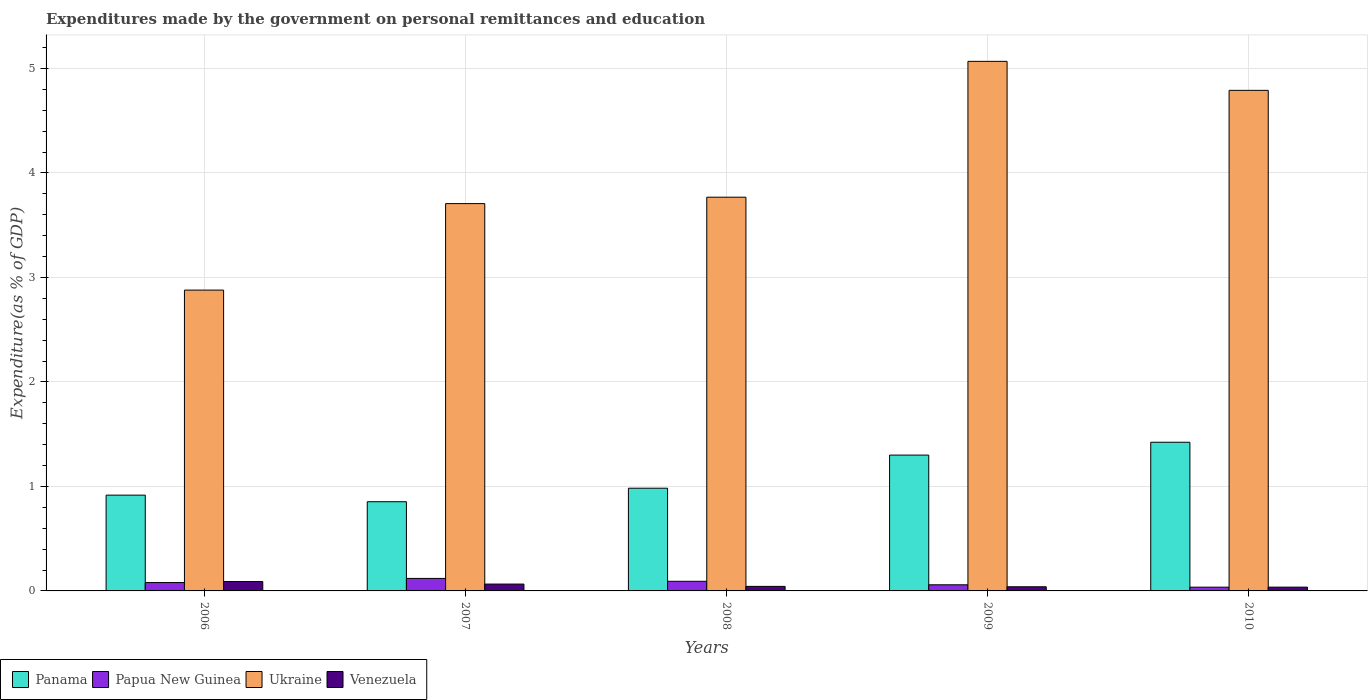Are the number of bars per tick equal to the number of legend labels?
Provide a short and direct response. Yes. Are the number of bars on each tick of the X-axis equal?
Provide a succinct answer. Yes. How many bars are there on the 1st tick from the left?
Your answer should be very brief. 4. How many bars are there on the 4th tick from the right?
Keep it short and to the point. 4. What is the label of the 2nd group of bars from the left?
Your response must be concise. 2007. What is the expenditures made by the government on personal remittances and education in Papua New Guinea in 2008?
Provide a short and direct response. 0.09. Across all years, what is the maximum expenditures made by the government on personal remittances and education in Ukraine?
Your answer should be compact. 5.07. Across all years, what is the minimum expenditures made by the government on personal remittances and education in Panama?
Give a very brief answer. 0.85. What is the total expenditures made by the government on personal remittances and education in Ukraine in the graph?
Give a very brief answer. 20.21. What is the difference between the expenditures made by the government on personal remittances and education in Venezuela in 2006 and that in 2007?
Your response must be concise. 0.02. What is the difference between the expenditures made by the government on personal remittances and education in Panama in 2010 and the expenditures made by the government on personal remittances and education in Venezuela in 2009?
Your response must be concise. 1.38. What is the average expenditures made by the government on personal remittances and education in Panama per year?
Your response must be concise. 1.1. In the year 2007, what is the difference between the expenditures made by the government on personal remittances and education in Papua New Guinea and expenditures made by the government on personal remittances and education in Ukraine?
Your answer should be very brief. -3.59. In how many years, is the expenditures made by the government on personal remittances and education in Ukraine greater than 2.4 %?
Keep it short and to the point. 5. What is the ratio of the expenditures made by the government on personal remittances and education in Venezuela in 2008 to that in 2009?
Ensure brevity in your answer.  1.09. What is the difference between the highest and the second highest expenditures made by the government on personal remittances and education in Panama?
Your response must be concise. 0.12. What is the difference between the highest and the lowest expenditures made by the government on personal remittances and education in Ukraine?
Your response must be concise. 2.19. What does the 2nd bar from the left in 2009 represents?
Offer a terse response. Papua New Guinea. What does the 3rd bar from the right in 2009 represents?
Keep it short and to the point. Papua New Guinea. How many bars are there?
Keep it short and to the point. 20. How many years are there in the graph?
Your answer should be compact. 5. Are the values on the major ticks of Y-axis written in scientific E-notation?
Keep it short and to the point. No. Does the graph contain any zero values?
Provide a succinct answer. No. Does the graph contain grids?
Keep it short and to the point. Yes. How are the legend labels stacked?
Your answer should be very brief. Horizontal. What is the title of the graph?
Provide a short and direct response. Expenditures made by the government on personal remittances and education. What is the label or title of the X-axis?
Offer a very short reply. Years. What is the label or title of the Y-axis?
Make the answer very short. Expenditure(as % of GDP). What is the Expenditure(as % of GDP) in Panama in 2006?
Offer a terse response. 0.92. What is the Expenditure(as % of GDP) of Papua New Guinea in 2006?
Give a very brief answer. 0.08. What is the Expenditure(as % of GDP) of Ukraine in 2006?
Offer a very short reply. 2.88. What is the Expenditure(as % of GDP) in Venezuela in 2006?
Offer a terse response. 0.09. What is the Expenditure(as % of GDP) of Panama in 2007?
Your answer should be compact. 0.85. What is the Expenditure(as % of GDP) in Papua New Guinea in 2007?
Make the answer very short. 0.12. What is the Expenditure(as % of GDP) of Ukraine in 2007?
Provide a short and direct response. 3.71. What is the Expenditure(as % of GDP) of Venezuela in 2007?
Provide a succinct answer. 0.07. What is the Expenditure(as % of GDP) of Panama in 2008?
Provide a short and direct response. 0.98. What is the Expenditure(as % of GDP) in Papua New Guinea in 2008?
Make the answer very short. 0.09. What is the Expenditure(as % of GDP) in Ukraine in 2008?
Provide a succinct answer. 3.77. What is the Expenditure(as % of GDP) of Venezuela in 2008?
Offer a very short reply. 0.04. What is the Expenditure(as % of GDP) in Panama in 2009?
Offer a terse response. 1.3. What is the Expenditure(as % of GDP) of Papua New Guinea in 2009?
Offer a terse response. 0.06. What is the Expenditure(as % of GDP) of Ukraine in 2009?
Make the answer very short. 5.07. What is the Expenditure(as % of GDP) in Venezuela in 2009?
Provide a succinct answer. 0.04. What is the Expenditure(as % of GDP) in Panama in 2010?
Provide a short and direct response. 1.42. What is the Expenditure(as % of GDP) of Papua New Guinea in 2010?
Your response must be concise. 0.04. What is the Expenditure(as % of GDP) of Ukraine in 2010?
Your answer should be very brief. 4.79. What is the Expenditure(as % of GDP) in Venezuela in 2010?
Provide a succinct answer. 0.04. Across all years, what is the maximum Expenditure(as % of GDP) of Panama?
Ensure brevity in your answer.  1.42. Across all years, what is the maximum Expenditure(as % of GDP) of Papua New Guinea?
Provide a succinct answer. 0.12. Across all years, what is the maximum Expenditure(as % of GDP) of Ukraine?
Offer a very short reply. 5.07. Across all years, what is the maximum Expenditure(as % of GDP) in Venezuela?
Offer a terse response. 0.09. Across all years, what is the minimum Expenditure(as % of GDP) in Panama?
Provide a succinct answer. 0.85. Across all years, what is the minimum Expenditure(as % of GDP) in Papua New Guinea?
Give a very brief answer. 0.04. Across all years, what is the minimum Expenditure(as % of GDP) in Ukraine?
Make the answer very short. 2.88. Across all years, what is the minimum Expenditure(as % of GDP) in Venezuela?
Ensure brevity in your answer.  0.04. What is the total Expenditure(as % of GDP) of Panama in the graph?
Offer a very short reply. 5.48. What is the total Expenditure(as % of GDP) in Papua New Guinea in the graph?
Your answer should be compact. 0.39. What is the total Expenditure(as % of GDP) in Ukraine in the graph?
Provide a short and direct response. 20.21. What is the total Expenditure(as % of GDP) of Venezuela in the graph?
Keep it short and to the point. 0.28. What is the difference between the Expenditure(as % of GDP) in Panama in 2006 and that in 2007?
Your answer should be very brief. 0.06. What is the difference between the Expenditure(as % of GDP) of Papua New Guinea in 2006 and that in 2007?
Your response must be concise. -0.04. What is the difference between the Expenditure(as % of GDP) in Ukraine in 2006 and that in 2007?
Provide a succinct answer. -0.83. What is the difference between the Expenditure(as % of GDP) in Venezuela in 2006 and that in 2007?
Offer a terse response. 0.02. What is the difference between the Expenditure(as % of GDP) in Panama in 2006 and that in 2008?
Your answer should be very brief. -0.07. What is the difference between the Expenditure(as % of GDP) in Papua New Guinea in 2006 and that in 2008?
Make the answer very short. -0.01. What is the difference between the Expenditure(as % of GDP) in Ukraine in 2006 and that in 2008?
Offer a terse response. -0.89. What is the difference between the Expenditure(as % of GDP) of Venezuela in 2006 and that in 2008?
Make the answer very short. 0.05. What is the difference between the Expenditure(as % of GDP) of Panama in 2006 and that in 2009?
Keep it short and to the point. -0.38. What is the difference between the Expenditure(as % of GDP) in Papua New Guinea in 2006 and that in 2009?
Keep it short and to the point. 0.02. What is the difference between the Expenditure(as % of GDP) in Ukraine in 2006 and that in 2009?
Give a very brief answer. -2.19. What is the difference between the Expenditure(as % of GDP) in Venezuela in 2006 and that in 2009?
Make the answer very short. 0.05. What is the difference between the Expenditure(as % of GDP) in Panama in 2006 and that in 2010?
Your response must be concise. -0.51. What is the difference between the Expenditure(as % of GDP) of Papua New Guinea in 2006 and that in 2010?
Give a very brief answer. 0.04. What is the difference between the Expenditure(as % of GDP) in Ukraine in 2006 and that in 2010?
Provide a succinct answer. -1.91. What is the difference between the Expenditure(as % of GDP) of Venezuela in 2006 and that in 2010?
Offer a very short reply. 0.05. What is the difference between the Expenditure(as % of GDP) of Panama in 2007 and that in 2008?
Your answer should be very brief. -0.13. What is the difference between the Expenditure(as % of GDP) in Papua New Guinea in 2007 and that in 2008?
Your response must be concise. 0.03. What is the difference between the Expenditure(as % of GDP) of Ukraine in 2007 and that in 2008?
Ensure brevity in your answer.  -0.06. What is the difference between the Expenditure(as % of GDP) in Venezuela in 2007 and that in 2008?
Ensure brevity in your answer.  0.02. What is the difference between the Expenditure(as % of GDP) in Panama in 2007 and that in 2009?
Keep it short and to the point. -0.45. What is the difference between the Expenditure(as % of GDP) of Papua New Guinea in 2007 and that in 2009?
Keep it short and to the point. 0.06. What is the difference between the Expenditure(as % of GDP) of Ukraine in 2007 and that in 2009?
Your answer should be very brief. -1.36. What is the difference between the Expenditure(as % of GDP) of Venezuela in 2007 and that in 2009?
Give a very brief answer. 0.03. What is the difference between the Expenditure(as % of GDP) in Panama in 2007 and that in 2010?
Your answer should be compact. -0.57. What is the difference between the Expenditure(as % of GDP) in Papua New Guinea in 2007 and that in 2010?
Make the answer very short. 0.08. What is the difference between the Expenditure(as % of GDP) in Ukraine in 2007 and that in 2010?
Provide a succinct answer. -1.08. What is the difference between the Expenditure(as % of GDP) in Venezuela in 2007 and that in 2010?
Keep it short and to the point. 0.03. What is the difference between the Expenditure(as % of GDP) of Panama in 2008 and that in 2009?
Make the answer very short. -0.32. What is the difference between the Expenditure(as % of GDP) of Papua New Guinea in 2008 and that in 2009?
Your response must be concise. 0.03. What is the difference between the Expenditure(as % of GDP) of Venezuela in 2008 and that in 2009?
Your response must be concise. 0. What is the difference between the Expenditure(as % of GDP) in Panama in 2008 and that in 2010?
Offer a very short reply. -0.44. What is the difference between the Expenditure(as % of GDP) in Papua New Guinea in 2008 and that in 2010?
Make the answer very short. 0.06. What is the difference between the Expenditure(as % of GDP) in Ukraine in 2008 and that in 2010?
Your answer should be very brief. -1.02. What is the difference between the Expenditure(as % of GDP) in Venezuela in 2008 and that in 2010?
Give a very brief answer. 0.01. What is the difference between the Expenditure(as % of GDP) in Panama in 2009 and that in 2010?
Your response must be concise. -0.12. What is the difference between the Expenditure(as % of GDP) of Papua New Guinea in 2009 and that in 2010?
Your response must be concise. 0.02. What is the difference between the Expenditure(as % of GDP) of Ukraine in 2009 and that in 2010?
Give a very brief answer. 0.28. What is the difference between the Expenditure(as % of GDP) of Venezuela in 2009 and that in 2010?
Ensure brevity in your answer.  0. What is the difference between the Expenditure(as % of GDP) of Panama in 2006 and the Expenditure(as % of GDP) of Papua New Guinea in 2007?
Provide a short and direct response. 0.8. What is the difference between the Expenditure(as % of GDP) of Panama in 2006 and the Expenditure(as % of GDP) of Ukraine in 2007?
Provide a short and direct response. -2.79. What is the difference between the Expenditure(as % of GDP) of Panama in 2006 and the Expenditure(as % of GDP) of Venezuela in 2007?
Your answer should be very brief. 0.85. What is the difference between the Expenditure(as % of GDP) in Papua New Guinea in 2006 and the Expenditure(as % of GDP) in Ukraine in 2007?
Your answer should be very brief. -3.63. What is the difference between the Expenditure(as % of GDP) in Papua New Guinea in 2006 and the Expenditure(as % of GDP) in Venezuela in 2007?
Keep it short and to the point. 0.01. What is the difference between the Expenditure(as % of GDP) of Ukraine in 2006 and the Expenditure(as % of GDP) of Venezuela in 2007?
Your answer should be very brief. 2.81. What is the difference between the Expenditure(as % of GDP) in Panama in 2006 and the Expenditure(as % of GDP) in Papua New Guinea in 2008?
Provide a short and direct response. 0.82. What is the difference between the Expenditure(as % of GDP) of Panama in 2006 and the Expenditure(as % of GDP) of Ukraine in 2008?
Offer a very short reply. -2.85. What is the difference between the Expenditure(as % of GDP) in Panama in 2006 and the Expenditure(as % of GDP) in Venezuela in 2008?
Provide a short and direct response. 0.87. What is the difference between the Expenditure(as % of GDP) in Papua New Guinea in 2006 and the Expenditure(as % of GDP) in Ukraine in 2008?
Provide a succinct answer. -3.69. What is the difference between the Expenditure(as % of GDP) of Papua New Guinea in 2006 and the Expenditure(as % of GDP) of Venezuela in 2008?
Your response must be concise. 0.04. What is the difference between the Expenditure(as % of GDP) of Ukraine in 2006 and the Expenditure(as % of GDP) of Venezuela in 2008?
Give a very brief answer. 2.84. What is the difference between the Expenditure(as % of GDP) in Panama in 2006 and the Expenditure(as % of GDP) in Papua New Guinea in 2009?
Offer a very short reply. 0.86. What is the difference between the Expenditure(as % of GDP) in Panama in 2006 and the Expenditure(as % of GDP) in Ukraine in 2009?
Offer a very short reply. -4.15. What is the difference between the Expenditure(as % of GDP) of Panama in 2006 and the Expenditure(as % of GDP) of Venezuela in 2009?
Your response must be concise. 0.88. What is the difference between the Expenditure(as % of GDP) in Papua New Guinea in 2006 and the Expenditure(as % of GDP) in Ukraine in 2009?
Your answer should be very brief. -4.99. What is the difference between the Expenditure(as % of GDP) of Papua New Guinea in 2006 and the Expenditure(as % of GDP) of Venezuela in 2009?
Your answer should be very brief. 0.04. What is the difference between the Expenditure(as % of GDP) in Ukraine in 2006 and the Expenditure(as % of GDP) in Venezuela in 2009?
Your answer should be compact. 2.84. What is the difference between the Expenditure(as % of GDP) of Panama in 2006 and the Expenditure(as % of GDP) of Papua New Guinea in 2010?
Your answer should be very brief. 0.88. What is the difference between the Expenditure(as % of GDP) in Panama in 2006 and the Expenditure(as % of GDP) in Ukraine in 2010?
Give a very brief answer. -3.87. What is the difference between the Expenditure(as % of GDP) of Panama in 2006 and the Expenditure(as % of GDP) of Venezuela in 2010?
Offer a terse response. 0.88. What is the difference between the Expenditure(as % of GDP) of Papua New Guinea in 2006 and the Expenditure(as % of GDP) of Ukraine in 2010?
Offer a very short reply. -4.71. What is the difference between the Expenditure(as % of GDP) in Papua New Guinea in 2006 and the Expenditure(as % of GDP) in Venezuela in 2010?
Offer a terse response. 0.04. What is the difference between the Expenditure(as % of GDP) of Ukraine in 2006 and the Expenditure(as % of GDP) of Venezuela in 2010?
Ensure brevity in your answer.  2.84. What is the difference between the Expenditure(as % of GDP) in Panama in 2007 and the Expenditure(as % of GDP) in Papua New Guinea in 2008?
Your answer should be very brief. 0.76. What is the difference between the Expenditure(as % of GDP) of Panama in 2007 and the Expenditure(as % of GDP) of Ukraine in 2008?
Your answer should be very brief. -2.91. What is the difference between the Expenditure(as % of GDP) of Panama in 2007 and the Expenditure(as % of GDP) of Venezuela in 2008?
Your answer should be compact. 0.81. What is the difference between the Expenditure(as % of GDP) in Papua New Guinea in 2007 and the Expenditure(as % of GDP) in Ukraine in 2008?
Your answer should be compact. -3.65. What is the difference between the Expenditure(as % of GDP) in Papua New Guinea in 2007 and the Expenditure(as % of GDP) in Venezuela in 2008?
Give a very brief answer. 0.08. What is the difference between the Expenditure(as % of GDP) in Ukraine in 2007 and the Expenditure(as % of GDP) in Venezuela in 2008?
Ensure brevity in your answer.  3.66. What is the difference between the Expenditure(as % of GDP) in Panama in 2007 and the Expenditure(as % of GDP) in Papua New Guinea in 2009?
Ensure brevity in your answer.  0.8. What is the difference between the Expenditure(as % of GDP) in Panama in 2007 and the Expenditure(as % of GDP) in Ukraine in 2009?
Offer a very short reply. -4.21. What is the difference between the Expenditure(as % of GDP) of Panama in 2007 and the Expenditure(as % of GDP) of Venezuela in 2009?
Provide a short and direct response. 0.81. What is the difference between the Expenditure(as % of GDP) of Papua New Guinea in 2007 and the Expenditure(as % of GDP) of Ukraine in 2009?
Your response must be concise. -4.95. What is the difference between the Expenditure(as % of GDP) of Papua New Guinea in 2007 and the Expenditure(as % of GDP) of Venezuela in 2009?
Ensure brevity in your answer.  0.08. What is the difference between the Expenditure(as % of GDP) in Ukraine in 2007 and the Expenditure(as % of GDP) in Venezuela in 2009?
Provide a short and direct response. 3.67. What is the difference between the Expenditure(as % of GDP) of Panama in 2007 and the Expenditure(as % of GDP) of Papua New Guinea in 2010?
Provide a succinct answer. 0.82. What is the difference between the Expenditure(as % of GDP) in Panama in 2007 and the Expenditure(as % of GDP) in Ukraine in 2010?
Offer a terse response. -3.94. What is the difference between the Expenditure(as % of GDP) of Panama in 2007 and the Expenditure(as % of GDP) of Venezuela in 2010?
Keep it short and to the point. 0.82. What is the difference between the Expenditure(as % of GDP) of Papua New Guinea in 2007 and the Expenditure(as % of GDP) of Ukraine in 2010?
Give a very brief answer. -4.67. What is the difference between the Expenditure(as % of GDP) in Papua New Guinea in 2007 and the Expenditure(as % of GDP) in Venezuela in 2010?
Keep it short and to the point. 0.08. What is the difference between the Expenditure(as % of GDP) in Ukraine in 2007 and the Expenditure(as % of GDP) in Venezuela in 2010?
Your answer should be very brief. 3.67. What is the difference between the Expenditure(as % of GDP) in Panama in 2008 and the Expenditure(as % of GDP) in Papua New Guinea in 2009?
Offer a terse response. 0.92. What is the difference between the Expenditure(as % of GDP) in Panama in 2008 and the Expenditure(as % of GDP) in Ukraine in 2009?
Offer a terse response. -4.08. What is the difference between the Expenditure(as % of GDP) in Panama in 2008 and the Expenditure(as % of GDP) in Venezuela in 2009?
Offer a very short reply. 0.94. What is the difference between the Expenditure(as % of GDP) of Papua New Guinea in 2008 and the Expenditure(as % of GDP) of Ukraine in 2009?
Your answer should be compact. -4.98. What is the difference between the Expenditure(as % of GDP) in Papua New Guinea in 2008 and the Expenditure(as % of GDP) in Venezuela in 2009?
Offer a terse response. 0.05. What is the difference between the Expenditure(as % of GDP) of Ukraine in 2008 and the Expenditure(as % of GDP) of Venezuela in 2009?
Offer a terse response. 3.73. What is the difference between the Expenditure(as % of GDP) of Panama in 2008 and the Expenditure(as % of GDP) of Papua New Guinea in 2010?
Offer a very short reply. 0.95. What is the difference between the Expenditure(as % of GDP) of Panama in 2008 and the Expenditure(as % of GDP) of Ukraine in 2010?
Give a very brief answer. -3.81. What is the difference between the Expenditure(as % of GDP) of Panama in 2008 and the Expenditure(as % of GDP) of Venezuela in 2010?
Offer a terse response. 0.95. What is the difference between the Expenditure(as % of GDP) in Papua New Guinea in 2008 and the Expenditure(as % of GDP) in Ukraine in 2010?
Offer a terse response. -4.7. What is the difference between the Expenditure(as % of GDP) of Papua New Guinea in 2008 and the Expenditure(as % of GDP) of Venezuela in 2010?
Give a very brief answer. 0.06. What is the difference between the Expenditure(as % of GDP) of Ukraine in 2008 and the Expenditure(as % of GDP) of Venezuela in 2010?
Provide a succinct answer. 3.73. What is the difference between the Expenditure(as % of GDP) of Panama in 2009 and the Expenditure(as % of GDP) of Papua New Guinea in 2010?
Your response must be concise. 1.26. What is the difference between the Expenditure(as % of GDP) in Panama in 2009 and the Expenditure(as % of GDP) in Ukraine in 2010?
Your response must be concise. -3.49. What is the difference between the Expenditure(as % of GDP) of Panama in 2009 and the Expenditure(as % of GDP) of Venezuela in 2010?
Offer a terse response. 1.26. What is the difference between the Expenditure(as % of GDP) of Papua New Guinea in 2009 and the Expenditure(as % of GDP) of Ukraine in 2010?
Offer a terse response. -4.73. What is the difference between the Expenditure(as % of GDP) in Papua New Guinea in 2009 and the Expenditure(as % of GDP) in Venezuela in 2010?
Offer a very short reply. 0.02. What is the difference between the Expenditure(as % of GDP) of Ukraine in 2009 and the Expenditure(as % of GDP) of Venezuela in 2010?
Provide a short and direct response. 5.03. What is the average Expenditure(as % of GDP) in Panama per year?
Make the answer very short. 1.1. What is the average Expenditure(as % of GDP) of Papua New Guinea per year?
Give a very brief answer. 0.08. What is the average Expenditure(as % of GDP) of Ukraine per year?
Offer a terse response. 4.04. What is the average Expenditure(as % of GDP) of Venezuela per year?
Provide a succinct answer. 0.06. In the year 2006, what is the difference between the Expenditure(as % of GDP) of Panama and Expenditure(as % of GDP) of Papua New Guinea?
Provide a short and direct response. 0.84. In the year 2006, what is the difference between the Expenditure(as % of GDP) of Panama and Expenditure(as % of GDP) of Ukraine?
Ensure brevity in your answer.  -1.96. In the year 2006, what is the difference between the Expenditure(as % of GDP) in Panama and Expenditure(as % of GDP) in Venezuela?
Make the answer very short. 0.83. In the year 2006, what is the difference between the Expenditure(as % of GDP) of Papua New Guinea and Expenditure(as % of GDP) of Ukraine?
Your answer should be very brief. -2.8. In the year 2006, what is the difference between the Expenditure(as % of GDP) of Papua New Guinea and Expenditure(as % of GDP) of Venezuela?
Make the answer very short. -0.01. In the year 2006, what is the difference between the Expenditure(as % of GDP) of Ukraine and Expenditure(as % of GDP) of Venezuela?
Offer a terse response. 2.79. In the year 2007, what is the difference between the Expenditure(as % of GDP) in Panama and Expenditure(as % of GDP) in Papua New Guinea?
Provide a short and direct response. 0.73. In the year 2007, what is the difference between the Expenditure(as % of GDP) of Panama and Expenditure(as % of GDP) of Ukraine?
Your answer should be compact. -2.85. In the year 2007, what is the difference between the Expenditure(as % of GDP) in Panama and Expenditure(as % of GDP) in Venezuela?
Offer a very short reply. 0.79. In the year 2007, what is the difference between the Expenditure(as % of GDP) of Papua New Guinea and Expenditure(as % of GDP) of Ukraine?
Provide a succinct answer. -3.59. In the year 2007, what is the difference between the Expenditure(as % of GDP) in Papua New Guinea and Expenditure(as % of GDP) in Venezuela?
Ensure brevity in your answer.  0.05. In the year 2007, what is the difference between the Expenditure(as % of GDP) of Ukraine and Expenditure(as % of GDP) of Venezuela?
Offer a very short reply. 3.64. In the year 2008, what is the difference between the Expenditure(as % of GDP) of Panama and Expenditure(as % of GDP) of Papua New Guinea?
Your response must be concise. 0.89. In the year 2008, what is the difference between the Expenditure(as % of GDP) in Panama and Expenditure(as % of GDP) in Ukraine?
Provide a succinct answer. -2.79. In the year 2008, what is the difference between the Expenditure(as % of GDP) in Panama and Expenditure(as % of GDP) in Venezuela?
Provide a short and direct response. 0.94. In the year 2008, what is the difference between the Expenditure(as % of GDP) in Papua New Guinea and Expenditure(as % of GDP) in Ukraine?
Offer a very short reply. -3.68. In the year 2008, what is the difference between the Expenditure(as % of GDP) in Papua New Guinea and Expenditure(as % of GDP) in Venezuela?
Provide a short and direct response. 0.05. In the year 2008, what is the difference between the Expenditure(as % of GDP) in Ukraine and Expenditure(as % of GDP) in Venezuela?
Offer a terse response. 3.72. In the year 2009, what is the difference between the Expenditure(as % of GDP) in Panama and Expenditure(as % of GDP) in Papua New Guinea?
Provide a succinct answer. 1.24. In the year 2009, what is the difference between the Expenditure(as % of GDP) of Panama and Expenditure(as % of GDP) of Ukraine?
Your answer should be compact. -3.77. In the year 2009, what is the difference between the Expenditure(as % of GDP) of Panama and Expenditure(as % of GDP) of Venezuela?
Offer a terse response. 1.26. In the year 2009, what is the difference between the Expenditure(as % of GDP) in Papua New Guinea and Expenditure(as % of GDP) in Ukraine?
Offer a terse response. -5.01. In the year 2009, what is the difference between the Expenditure(as % of GDP) of Papua New Guinea and Expenditure(as % of GDP) of Venezuela?
Make the answer very short. 0.02. In the year 2009, what is the difference between the Expenditure(as % of GDP) in Ukraine and Expenditure(as % of GDP) in Venezuela?
Your answer should be very brief. 5.03. In the year 2010, what is the difference between the Expenditure(as % of GDP) of Panama and Expenditure(as % of GDP) of Papua New Guinea?
Provide a short and direct response. 1.39. In the year 2010, what is the difference between the Expenditure(as % of GDP) in Panama and Expenditure(as % of GDP) in Ukraine?
Ensure brevity in your answer.  -3.37. In the year 2010, what is the difference between the Expenditure(as % of GDP) in Panama and Expenditure(as % of GDP) in Venezuela?
Provide a short and direct response. 1.39. In the year 2010, what is the difference between the Expenditure(as % of GDP) of Papua New Guinea and Expenditure(as % of GDP) of Ukraine?
Offer a terse response. -4.75. In the year 2010, what is the difference between the Expenditure(as % of GDP) in Papua New Guinea and Expenditure(as % of GDP) in Venezuela?
Make the answer very short. -0. In the year 2010, what is the difference between the Expenditure(as % of GDP) in Ukraine and Expenditure(as % of GDP) in Venezuela?
Your answer should be compact. 4.75. What is the ratio of the Expenditure(as % of GDP) in Panama in 2006 to that in 2007?
Your response must be concise. 1.07. What is the ratio of the Expenditure(as % of GDP) of Papua New Guinea in 2006 to that in 2007?
Keep it short and to the point. 0.67. What is the ratio of the Expenditure(as % of GDP) in Ukraine in 2006 to that in 2007?
Offer a very short reply. 0.78. What is the ratio of the Expenditure(as % of GDP) in Venezuela in 2006 to that in 2007?
Your response must be concise. 1.37. What is the ratio of the Expenditure(as % of GDP) in Panama in 2006 to that in 2008?
Your answer should be very brief. 0.93. What is the ratio of the Expenditure(as % of GDP) in Papua New Guinea in 2006 to that in 2008?
Your answer should be compact. 0.87. What is the ratio of the Expenditure(as % of GDP) of Ukraine in 2006 to that in 2008?
Make the answer very short. 0.76. What is the ratio of the Expenditure(as % of GDP) of Venezuela in 2006 to that in 2008?
Ensure brevity in your answer.  2.07. What is the ratio of the Expenditure(as % of GDP) of Panama in 2006 to that in 2009?
Make the answer very short. 0.71. What is the ratio of the Expenditure(as % of GDP) of Papua New Guinea in 2006 to that in 2009?
Keep it short and to the point. 1.36. What is the ratio of the Expenditure(as % of GDP) in Ukraine in 2006 to that in 2009?
Your response must be concise. 0.57. What is the ratio of the Expenditure(as % of GDP) in Venezuela in 2006 to that in 2009?
Make the answer very short. 2.26. What is the ratio of the Expenditure(as % of GDP) in Panama in 2006 to that in 2010?
Provide a short and direct response. 0.64. What is the ratio of the Expenditure(as % of GDP) in Papua New Guinea in 2006 to that in 2010?
Your response must be concise. 2.22. What is the ratio of the Expenditure(as % of GDP) of Ukraine in 2006 to that in 2010?
Keep it short and to the point. 0.6. What is the ratio of the Expenditure(as % of GDP) in Venezuela in 2006 to that in 2010?
Your response must be concise. 2.48. What is the ratio of the Expenditure(as % of GDP) in Panama in 2007 to that in 2008?
Your answer should be compact. 0.87. What is the ratio of the Expenditure(as % of GDP) in Papua New Guinea in 2007 to that in 2008?
Offer a very short reply. 1.3. What is the ratio of the Expenditure(as % of GDP) in Ukraine in 2007 to that in 2008?
Offer a terse response. 0.98. What is the ratio of the Expenditure(as % of GDP) in Venezuela in 2007 to that in 2008?
Keep it short and to the point. 1.51. What is the ratio of the Expenditure(as % of GDP) of Panama in 2007 to that in 2009?
Offer a terse response. 0.66. What is the ratio of the Expenditure(as % of GDP) of Papua New Guinea in 2007 to that in 2009?
Your answer should be compact. 2.04. What is the ratio of the Expenditure(as % of GDP) of Ukraine in 2007 to that in 2009?
Your response must be concise. 0.73. What is the ratio of the Expenditure(as % of GDP) in Venezuela in 2007 to that in 2009?
Offer a terse response. 1.65. What is the ratio of the Expenditure(as % of GDP) of Panama in 2007 to that in 2010?
Offer a terse response. 0.6. What is the ratio of the Expenditure(as % of GDP) in Papua New Guinea in 2007 to that in 2010?
Your answer should be compact. 3.33. What is the ratio of the Expenditure(as % of GDP) in Ukraine in 2007 to that in 2010?
Your answer should be very brief. 0.77. What is the ratio of the Expenditure(as % of GDP) of Venezuela in 2007 to that in 2010?
Give a very brief answer. 1.81. What is the ratio of the Expenditure(as % of GDP) of Panama in 2008 to that in 2009?
Your answer should be very brief. 0.76. What is the ratio of the Expenditure(as % of GDP) in Papua New Guinea in 2008 to that in 2009?
Make the answer very short. 1.57. What is the ratio of the Expenditure(as % of GDP) in Ukraine in 2008 to that in 2009?
Ensure brevity in your answer.  0.74. What is the ratio of the Expenditure(as % of GDP) of Venezuela in 2008 to that in 2009?
Your answer should be very brief. 1.09. What is the ratio of the Expenditure(as % of GDP) of Panama in 2008 to that in 2010?
Your response must be concise. 0.69. What is the ratio of the Expenditure(as % of GDP) of Papua New Guinea in 2008 to that in 2010?
Your answer should be very brief. 2.56. What is the ratio of the Expenditure(as % of GDP) in Ukraine in 2008 to that in 2010?
Offer a terse response. 0.79. What is the ratio of the Expenditure(as % of GDP) of Venezuela in 2008 to that in 2010?
Offer a terse response. 1.2. What is the ratio of the Expenditure(as % of GDP) of Panama in 2009 to that in 2010?
Keep it short and to the point. 0.91. What is the ratio of the Expenditure(as % of GDP) of Papua New Guinea in 2009 to that in 2010?
Provide a succinct answer. 1.63. What is the ratio of the Expenditure(as % of GDP) in Ukraine in 2009 to that in 2010?
Your answer should be compact. 1.06. What is the ratio of the Expenditure(as % of GDP) in Venezuela in 2009 to that in 2010?
Your response must be concise. 1.1. What is the difference between the highest and the second highest Expenditure(as % of GDP) of Panama?
Your answer should be very brief. 0.12. What is the difference between the highest and the second highest Expenditure(as % of GDP) of Papua New Guinea?
Your answer should be very brief. 0.03. What is the difference between the highest and the second highest Expenditure(as % of GDP) in Ukraine?
Your answer should be compact. 0.28. What is the difference between the highest and the second highest Expenditure(as % of GDP) in Venezuela?
Give a very brief answer. 0.02. What is the difference between the highest and the lowest Expenditure(as % of GDP) in Panama?
Your answer should be compact. 0.57. What is the difference between the highest and the lowest Expenditure(as % of GDP) in Papua New Guinea?
Offer a very short reply. 0.08. What is the difference between the highest and the lowest Expenditure(as % of GDP) of Ukraine?
Your answer should be compact. 2.19. What is the difference between the highest and the lowest Expenditure(as % of GDP) of Venezuela?
Keep it short and to the point. 0.05. 